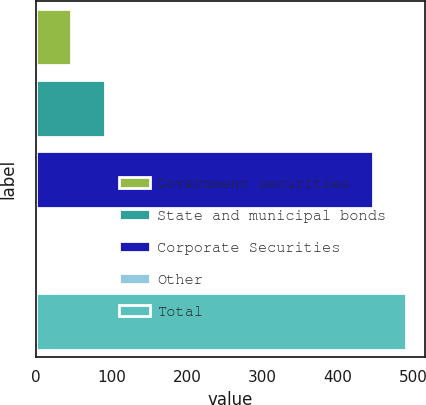Convert chart. <chart><loc_0><loc_0><loc_500><loc_500><bar_chart><fcel>Government securities<fcel>State and municipal bonds<fcel>Corporate Securities<fcel>Other<fcel>Total<nl><fcel>46.44<fcel>90.84<fcel>446<fcel>2.04<fcel>490.4<nl></chart> 